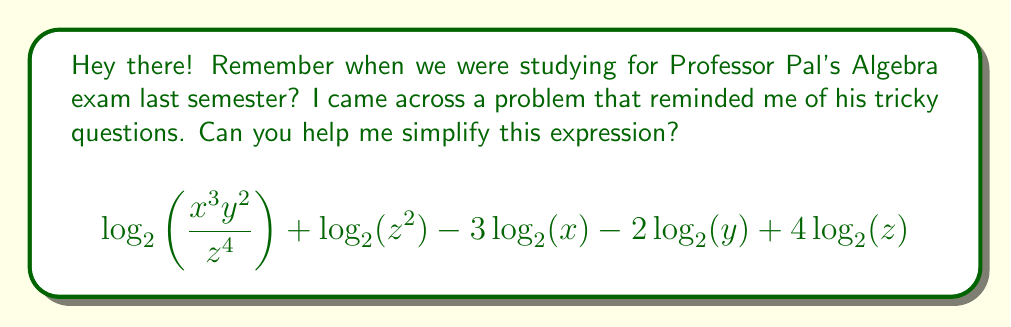Can you answer this question? Let's approach this step-by-step:

1) First, recall the logarithm properties:
   - $\log_a(MN) = \log_a(M) + \log_a(N)$
   - $\log_a(M/N) = \log_a(M) - \log_a(N)$
   - $\log_a(M^n) = n\log_a(M)$

2) Let's start with the first term:
   $$\log_2\left(\frac{x^3y^2}{z^4}\right) = \log_2(x^3) + \log_2(y^2) - \log_2(z^4)$$

3) Now, apply the power property:
   $$= 3\log_2(x) + 2\log_2(y) - 4\log_2(z)$$

4) The expression now becomes:
   $$(3\log_2(x) + 2\log_2(y) - 4\log_2(z)) + \log_2(z^2) - 3\log_2(x) - 2\log_2(y) + 4\log_2(z)$$

5) Apply the power property to $\log_2(z^2)$:
   $$(3\log_2(x) + 2\log_2(y) - 4\log_2(z)) + 2\log_2(z) - 3\log_2(x) - 2\log_2(y) + 4\log_2(z)$$

6) Now, let's group like terms:
   $$(3\log_2(x) - 3\log_2(x)) + (2\log_2(y) - 2\log_2(y)) + (-4\log_2(z) + 2\log_2(z) + 4\log_2(z))$$

7) Simplify:
   $$0 + 0 + 2\log_2(z)$$

Therefore, the expression simplifies to $2\log_2(z)$.
Answer: $2\log_2(z)$ 